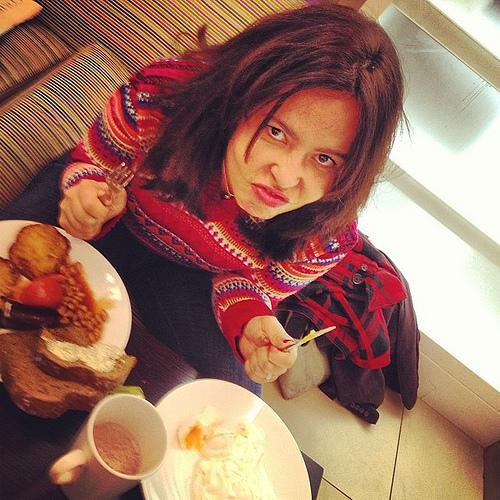Question: how many people?
Choices:
A. 2.
B. 4.
C. 3.
D. 1.
Answer with the letter. Answer: D Question: what is on the plate?
Choices:
A. Food.
B. French fries.
C. A fork.
D. Napkins.
Answer with the letter. Answer: A Question: where is the knife?
Choices:
A. In the knife block.
B. In her hand.
C. On the counter.
D. On the plater.
Answer with the letter. Answer: B Question: who is not smiling?
Choices:
A. The man.
B. The child.
C. The baby.
D. The woman.
Answer with the letter. Answer: D 